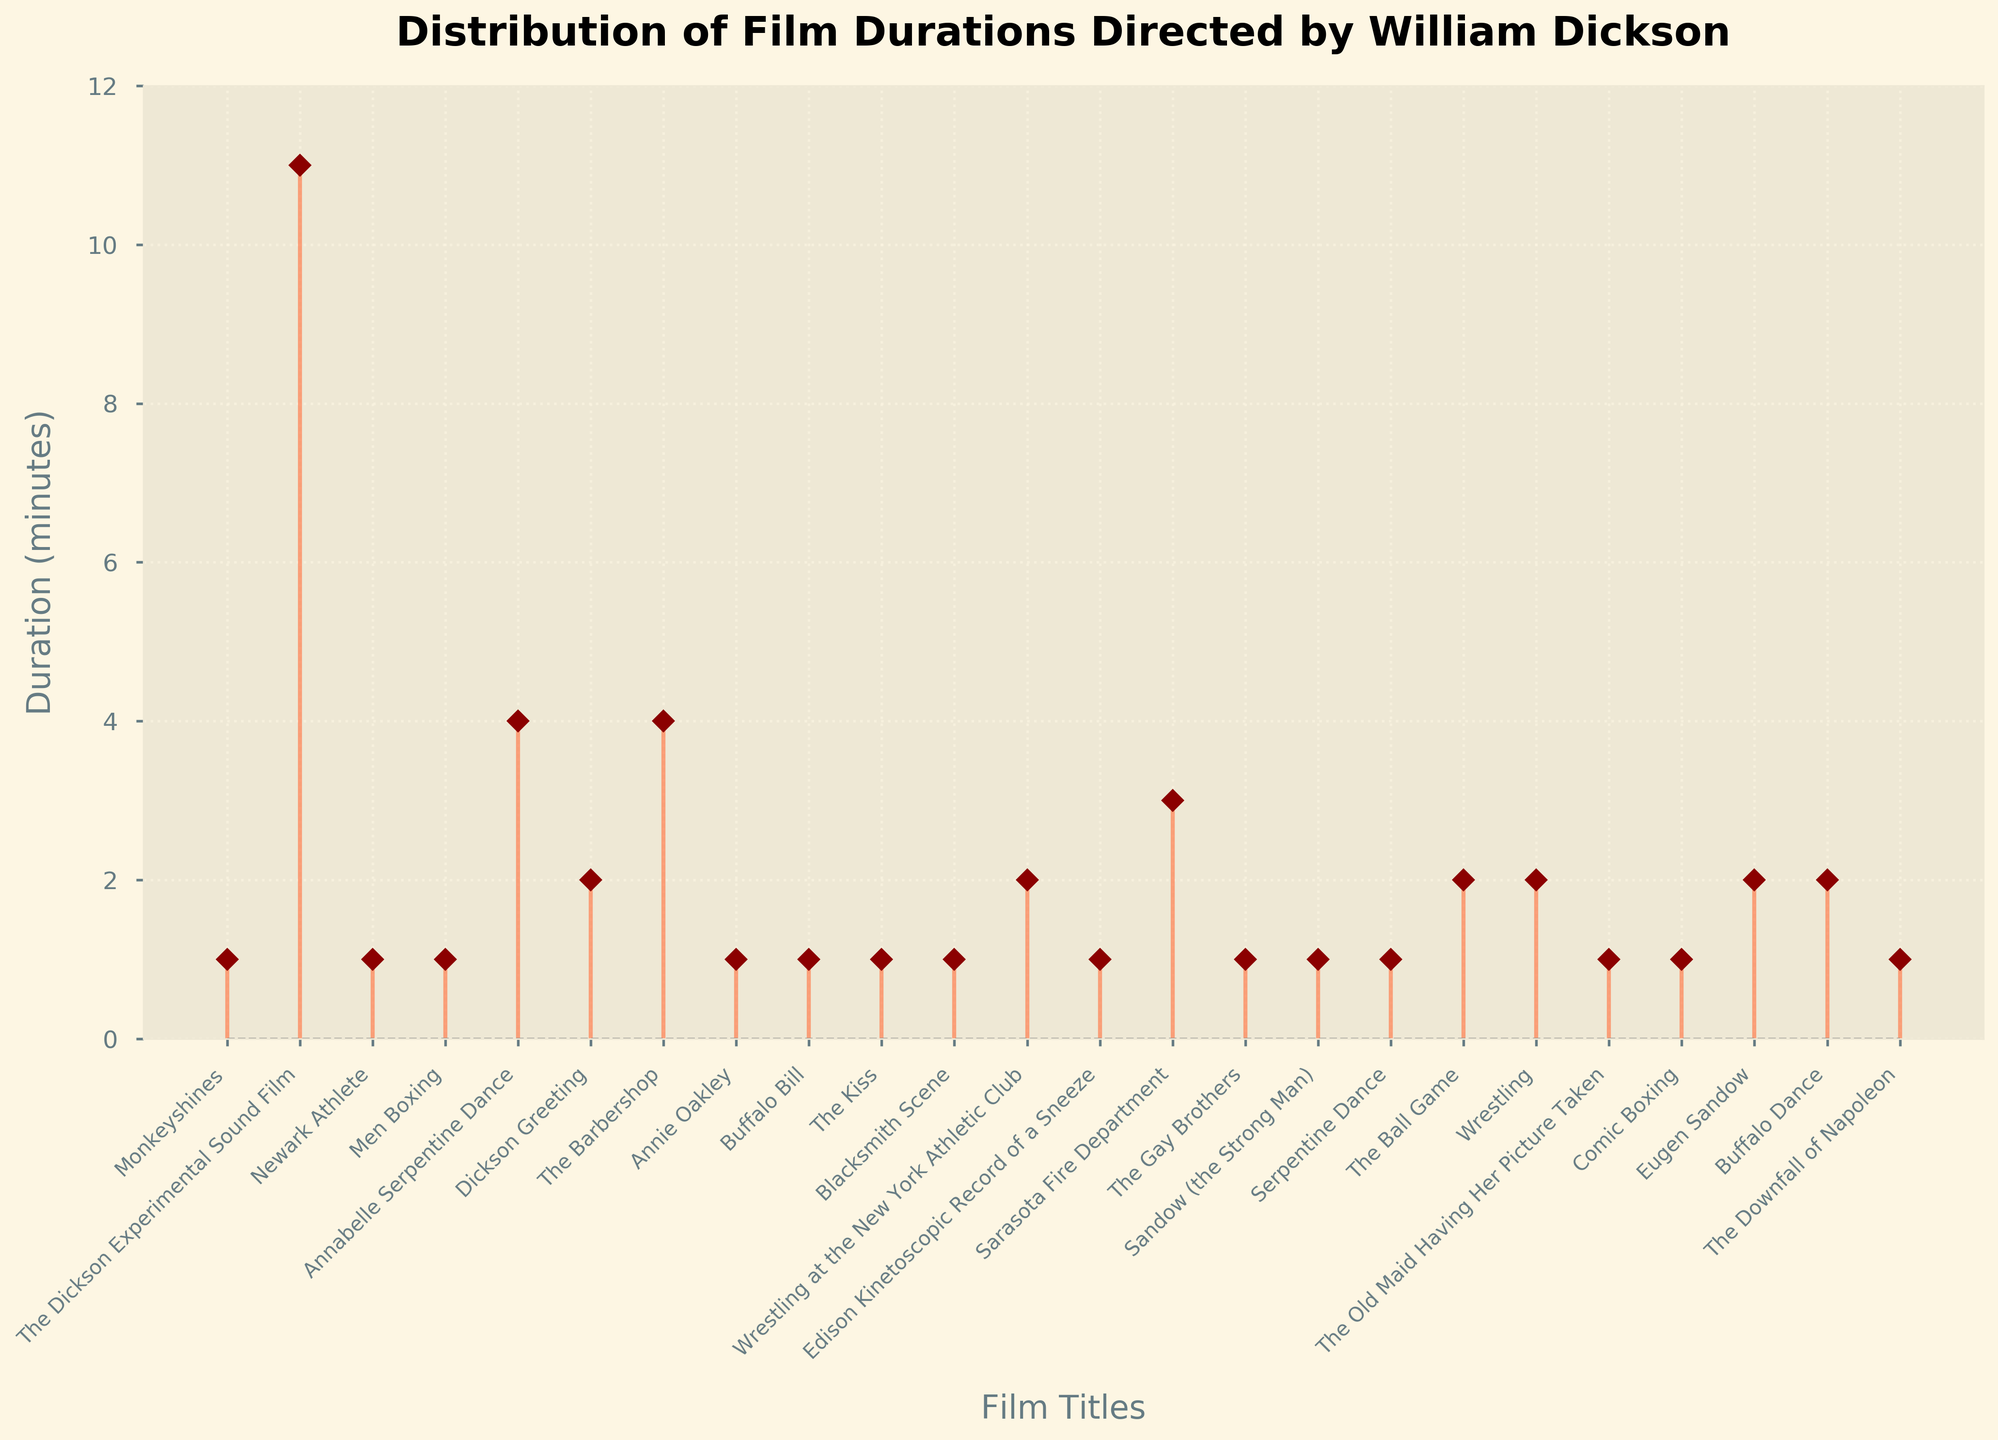what is the duration of the longest film in the plot? The longest film can be identified by finding the stem with the highest value on the y-axis. The "Dickson Experimental Sound Film" has the highest stem at 11 minutes.
Answer: 11 minutes What is the title of the shortest films shown in the plot? The shortest films can be identified by looking for films with the lowest value on the y-axis. Several films share the shortest duration of 1 minute. Some examples are "Monkeyshines", "Newark Athlete", and "Men Boxing".
Answer: Monkeyshines, Newark Athlete, Men Boxing, etc How many films have a duration of 2 minutes? Count the number of stems that reach the y-axis value of 2. There are six films with a duration of 2 minutes.
Answer: 6 films Which film has the highest duration, and what is its total duration? The film with the highest duration is identified by finding the stem with the highest point on the y-axis. The "Dickson Experimental Sound Film" has a duration of 11 minutes.
Answer: Dickson Experimental Sound Film, 11 minutes What is the median duration of the films? To find the median, list all film durations in ascending order and identify the middle value. Ordered durations: [1, 1, 1, 1, 1, 1, 1, 1, 1, 1, 2, 2, 2, 2, 2, 2, 3, 4, 4, 11]. The median is the average of the tenth and eleventh values, which are both 1 and 2. So, the median is 1.5.
Answer: 1.5 minutes Which films have durations greater than 3 minutes but less than 11 minutes? Look for stems where the y-axis value falls between 3 and 11, excluding both. The films are "Annabelle Serpentine Dance" and "The Barbershop", each with a duration of 4 minutes.
Answer: Annabelle Serpentine Dance, The Barbershop How many films are directed by William Dickson have durations between 1 and 3 minutes including both? Count the number of stems that fall within the duration range of 1 to 3 inclusive. There are 20 films with durations between 1 and 3 minutes, including both.
Answer: 20 films How does the number of 1-minute duration films compare to 4-minute duration films? Count the number of stems at the y-axis values of 1 and 4, then compare. There are 10 films at 1 minute and 2 films at 4 minutes. So, the number of 1-minute films is five times the number of 4-minute films.
Answer: 10 vs. 2 